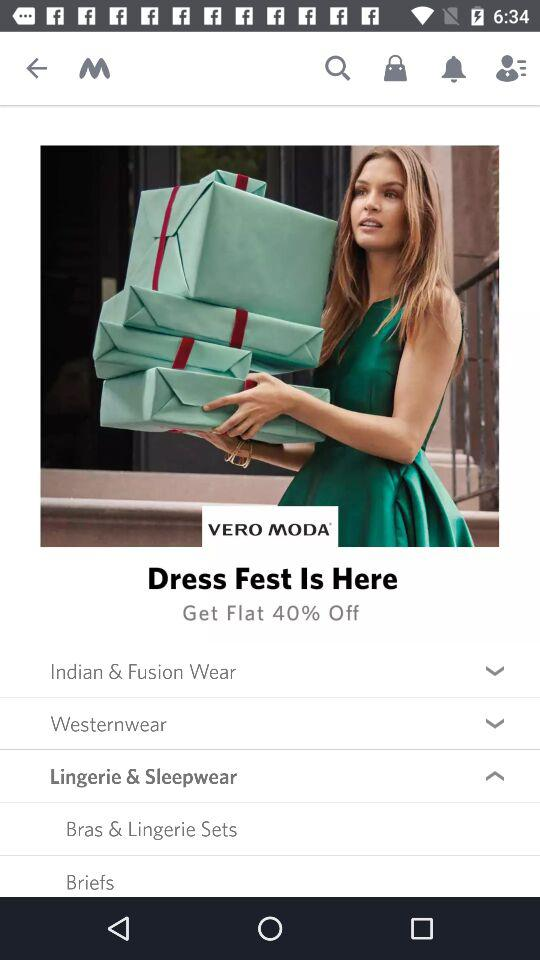How much is the dress fest discount? The discount is 40%. 